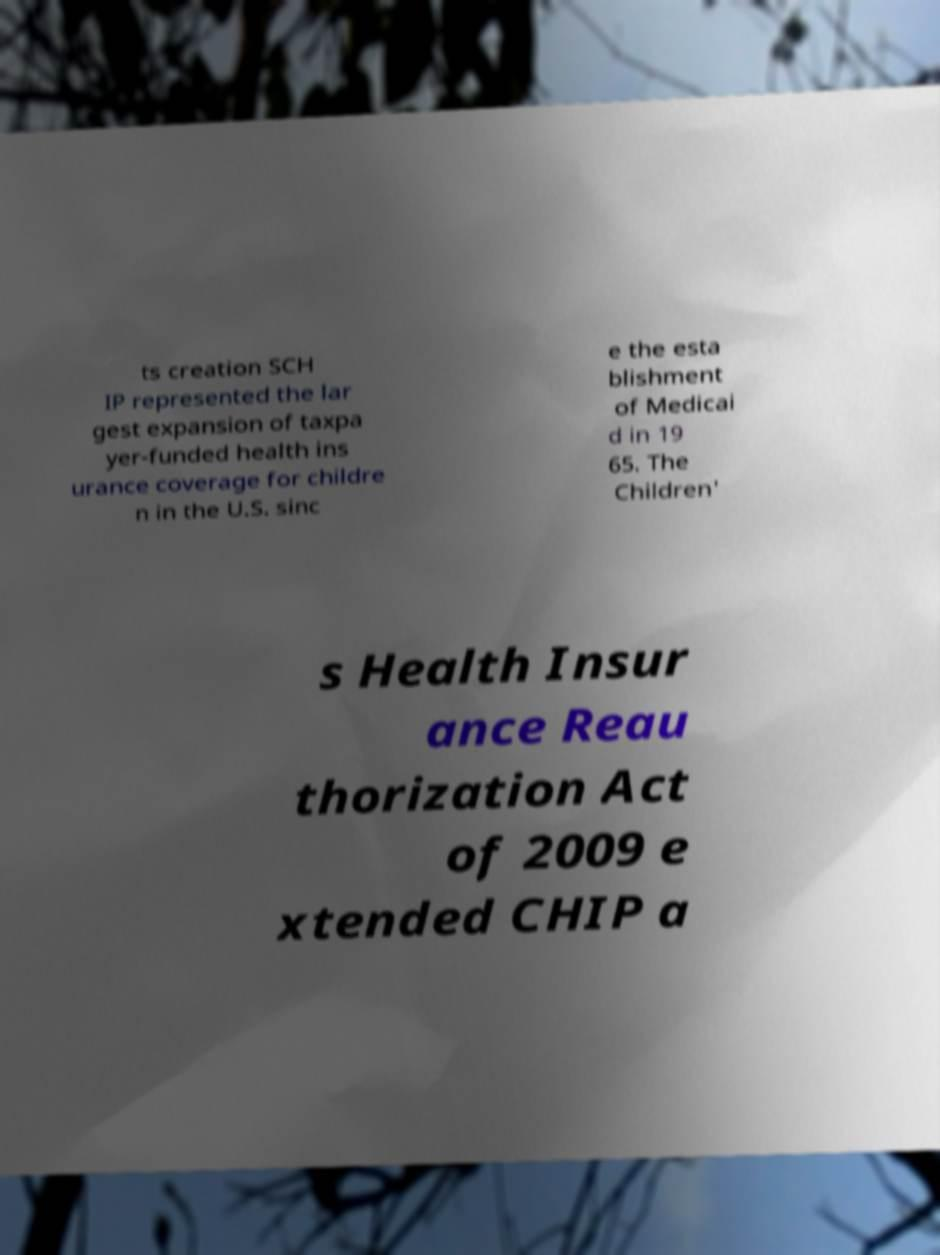Can you accurately transcribe the text from the provided image for me? ts creation SCH IP represented the lar gest expansion of taxpa yer-funded health ins urance coverage for childre n in the U.S. sinc e the esta blishment of Medicai d in 19 65. The Children' s Health Insur ance Reau thorization Act of 2009 e xtended CHIP a 